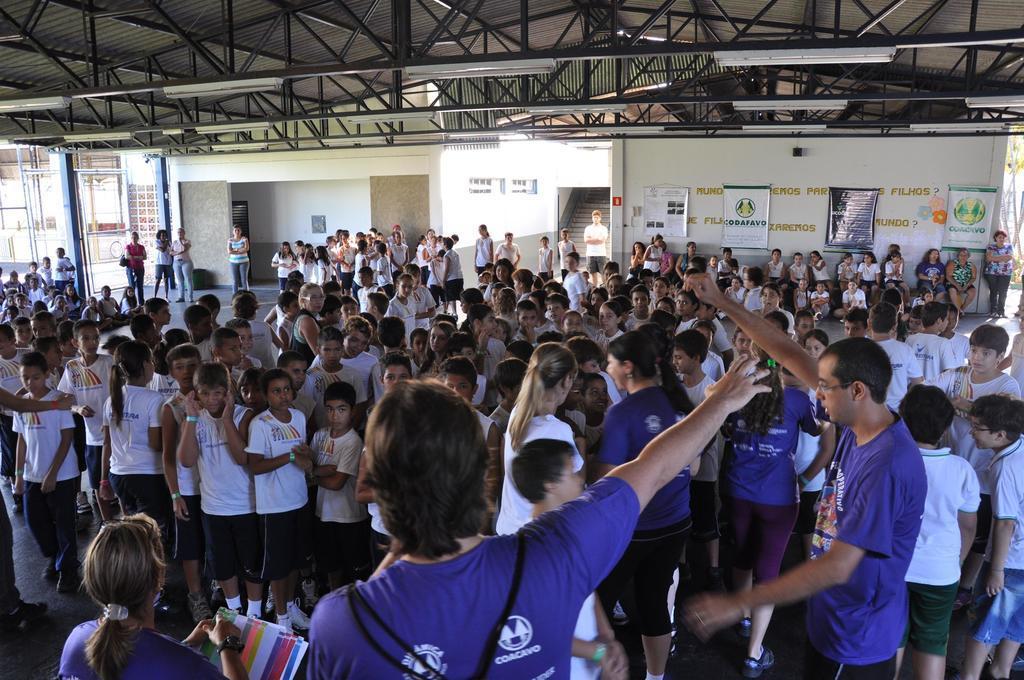Could you give a brief overview of what you see in this image? In this image we can see people standing on the floor. In the background there are advertisements attached to the walls, staircase, sign boards and grills. 